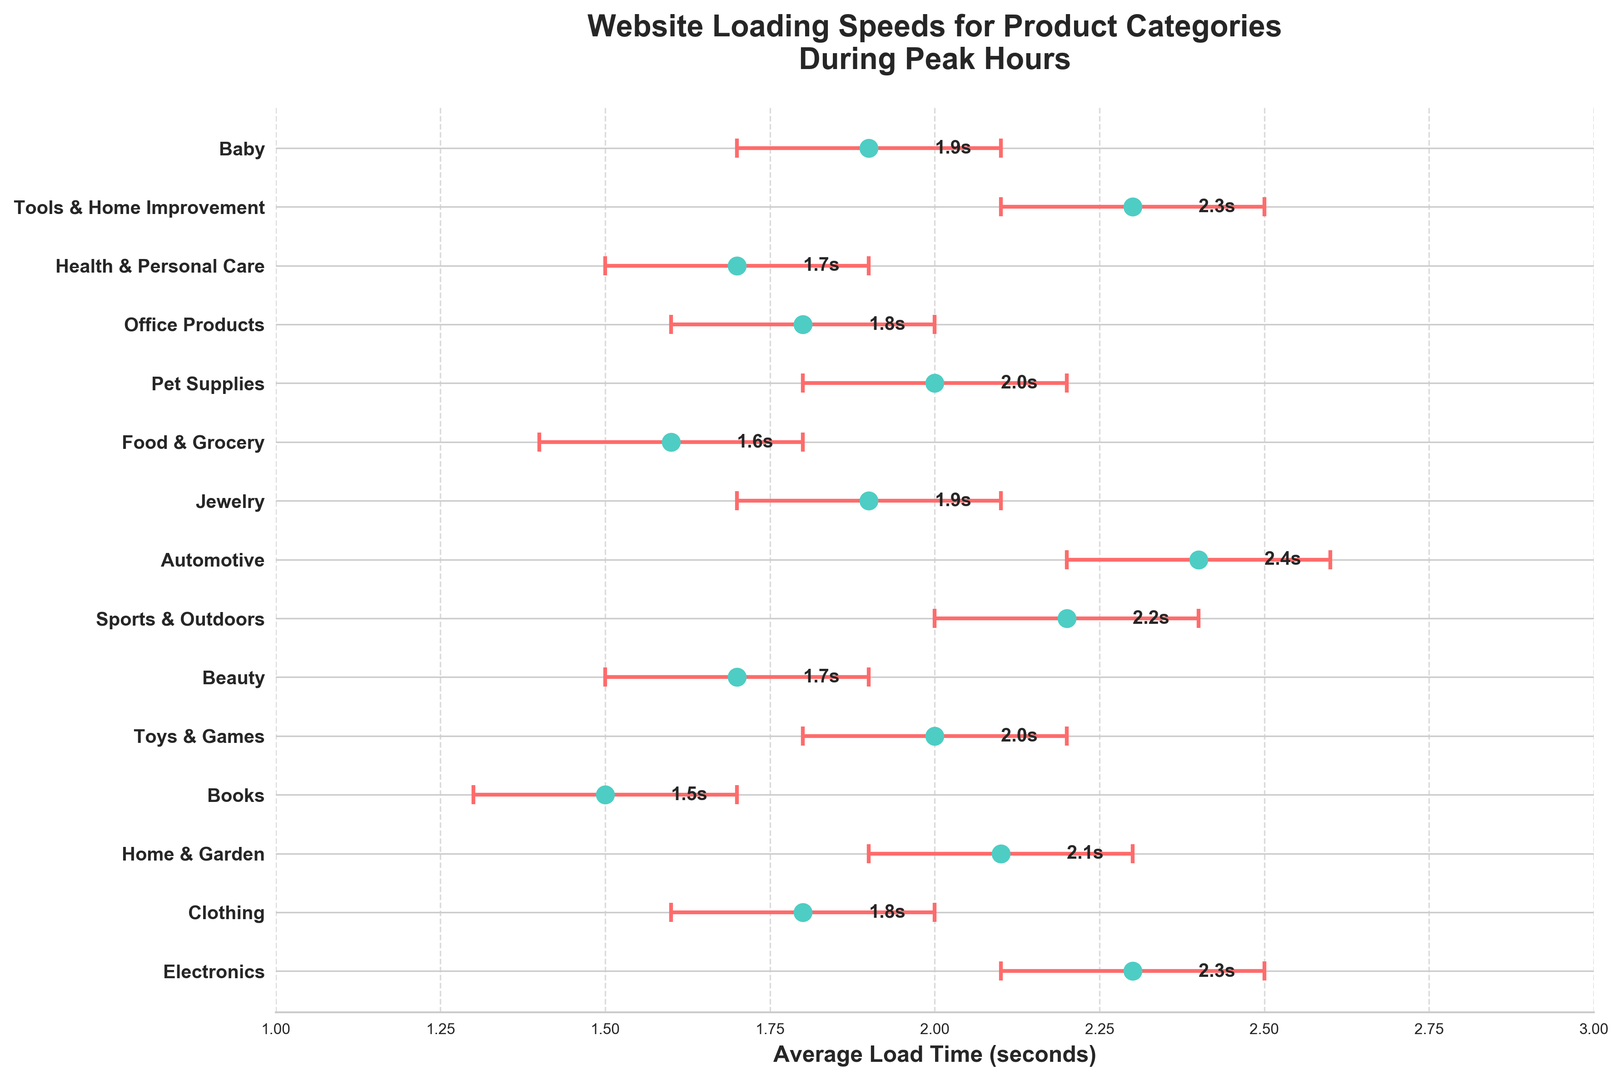What's the category with the highest average load time? Locate the longest horizontal bar in the figure which represents the average load time. The category with the longest bar is Automotive.
Answer: Automotive Which category has the narrowest confidence interval? Compare the error bars representing the confidence intervals of each category. The category with the smallest range of error bars is Books.
Answer: Books How much faster is Food & Grocery compared to Electronics? Find the average load times for Food & Grocery and Electronics. Subtract the average load time of Food & Grocery (1.6s) from that of Electronics (2.3s).
Answer: 0.7s What's the average of the average load times for Beauty and Health & Personal Care? Find the average load times for Beauty (1.7s) and Health & Personal Care (1.7s). Average these two values: (1.7 + 1.7) / 2.
Answer: 1.7s Which categories have a lower average load time compared to the 'Toys & Games' category? Compare the average load times of all categories to that of Toys & Games (2.0s). List the categories with average load times less than 2.0s.
Answer: Clothing, Books, Beauty, Food & Grocery, Health & Personal Care Does 'Tools & Home Improvement' have an average load time greater than 'Home & Garden'? Compare the average load time of Tools & Home Improvement (2.3s) to that of Home & Garden (2.1s).
Answer: Yes Which category's load time is closest to 2.0 seconds? Identify the category with an average load time nearest to 2.0s. The closest category is Toys & Games.
Answer: Toys & Games How many categories have average load times above 2.0 seconds? Count the categories with average load times greater than 2.0s. These categories are Electronics, Sports & Outdoors, Automotive, and Tools & Home Improvement, totaling 4.
Answer: 4 In which categories do the confidence intervals include 2.0 seconds? Check the lower and upper confidence intervals for each category to see if 2.0 seconds falls within these ranges. The categories are Toys & Games, Sports & Outdoors, Jewelry, Pet Supplies, and Baby.
Answer: Toys & Games, Sports & Outdoors, Jewelry, Pet Supplies, Baby What's the total range of average load times across all categories? Find the highest and lowest average load times. The highest is Automotive (2.4s) and the lowest is Books (1.5s). Subtract the lowest from the highest: 2.4 - 1.5.
Answer: 0.9s 